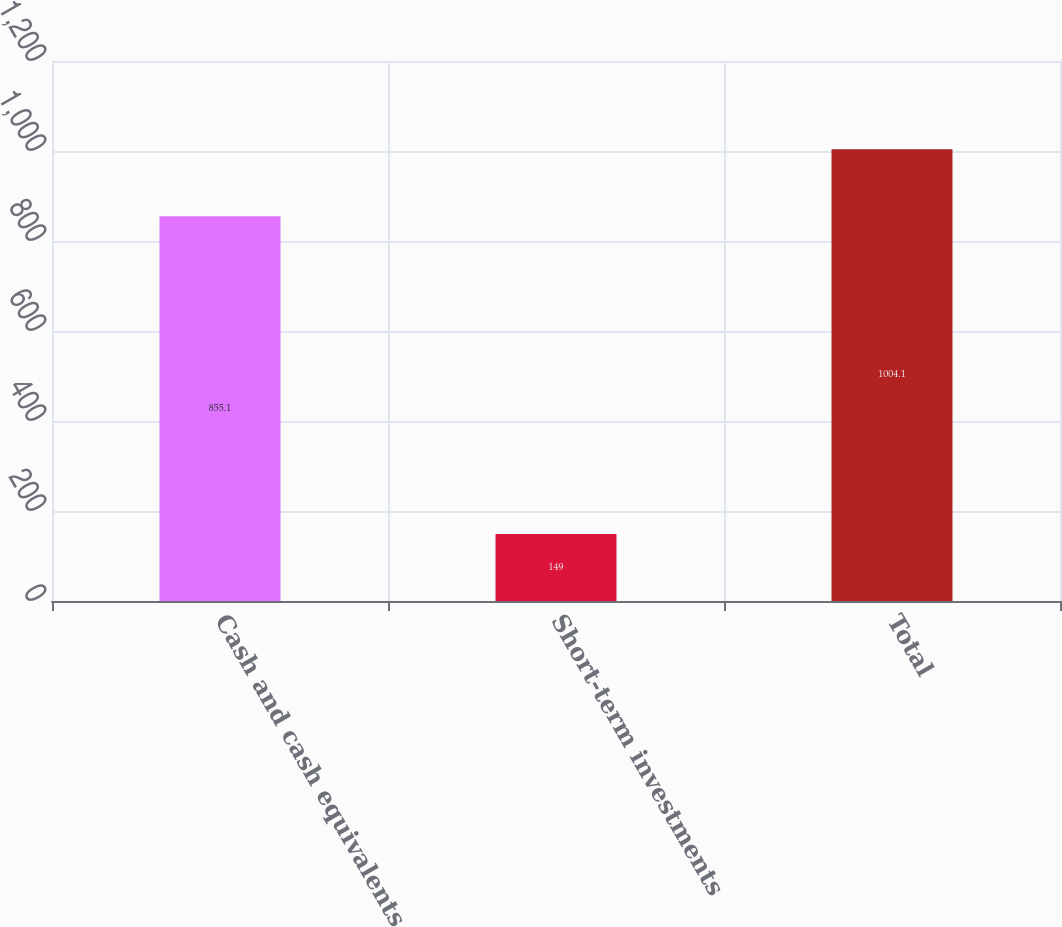Convert chart to OTSL. <chart><loc_0><loc_0><loc_500><loc_500><bar_chart><fcel>Cash and cash equivalents<fcel>Short-term investments<fcel>Total<nl><fcel>855.1<fcel>149<fcel>1004.1<nl></chart> 